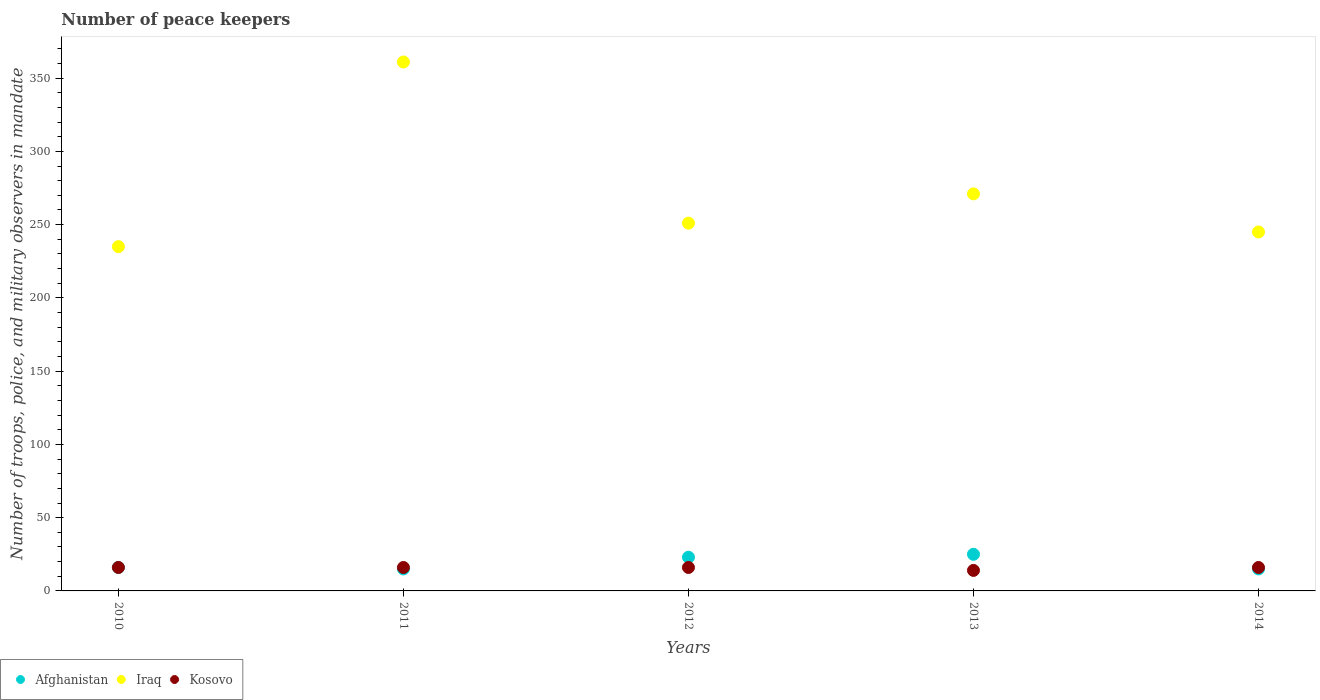What is the number of peace keepers in in Afghanistan in 2014?
Give a very brief answer. 15. Across all years, what is the maximum number of peace keepers in in Afghanistan?
Provide a short and direct response. 25. Across all years, what is the minimum number of peace keepers in in Iraq?
Make the answer very short. 235. In which year was the number of peace keepers in in Afghanistan maximum?
Offer a terse response. 2013. In which year was the number of peace keepers in in Kosovo minimum?
Your response must be concise. 2013. What is the difference between the number of peace keepers in in Iraq in 2013 and the number of peace keepers in in Afghanistan in 2014?
Your answer should be compact. 256. What is the average number of peace keepers in in Iraq per year?
Offer a very short reply. 272.6. In the year 2013, what is the difference between the number of peace keepers in in Kosovo and number of peace keepers in in Iraq?
Make the answer very short. -257. What is the ratio of the number of peace keepers in in Iraq in 2013 to that in 2014?
Provide a succinct answer. 1.11. What is the difference between the highest and the second highest number of peace keepers in in Iraq?
Provide a succinct answer. 90. What is the difference between the highest and the lowest number of peace keepers in in Afghanistan?
Offer a very short reply. 10. In how many years, is the number of peace keepers in in Afghanistan greater than the average number of peace keepers in in Afghanistan taken over all years?
Offer a very short reply. 2. Does the number of peace keepers in in Kosovo monotonically increase over the years?
Ensure brevity in your answer.  No. Is the number of peace keepers in in Iraq strictly less than the number of peace keepers in in Afghanistan over the years?
Make the answer very short. No. How many dotlines are there?
Your response must be concise. 3. How many years are there in the graph?
Give a very brief answer. 5. Does the graph contain any zero values?
Give a very brief answer. No. How many legend labels are there?
Offer a very short reply. 3. How are the legend labels stacked?
Offer a terse response. Horizontal. What is the title of the graph?
Your answer should be very brief. Number of peace keepers. Does "Malaysia" appear as one of the legend labels in the graph?
Ensure brevity in your answer.  No. What is the label or title of the Y-axis?
Your answer should be very brief. Number of troops, police, and military observers in mandate. What is the Number of troops, police, and military observers in mandate in Iraq in 2010?
Your answer should be very brief. 235. What is the Number of troops, police, and military observers in mandate in Afghanistan in 2011?
Provide a short and direct response. 15. What is the Number of troops, police, and military observers in mandate in Iraq in 2011?
Provide a short and direct response. 361. What is the Number of troops, police, and military observers in mandate of Iraq in 2012?
Make the answer very short. 251. What is the Number of troops, police, and military observers in mandate in Kosovo in 2012?
Provide a succinct answer. 16. What is the Number of troops, police, and military observers in mandate of Iraq in 2013?
Your answer should be compact. 271. What is the Number of troops, police, and military observers in mandate in Kosovo in 2013?
Your answer should be compact. 14. What is the Number of troops, police, and military observers in mandate in Afghanistan in 2014?
Make the answer very short. 15. What is the Number of troops, police, and military observers in mandate in Iraq in 2014?
Offer a very short reply. 245. Across all years, what is the maximum Number of troops, police, and military observers in mandate in Afghanistan?
Provide a succinct answer. 25. Across all years, what is the maximum Number of troops, police, and military observers in mandate in Iraq?
Provide a succinct answer. 361. Across all years, what is the minimum Number of troops, police, and military observers in mandate in Afghanistan?
Offer a very short reply. 15. Across all years, what is the minimum Number of troops, police, and military observers in mandate in Iraq?
Offer a terse response. 235. What is the total Number of troops, police, and military observers in mandate in Afghanistan in the graph?
Your response must be concise. 94. What is the total Number of troops, police, and military observers in mandate of Iraq in the graph?
Offer a terse response. 1363. What is the difference between the Number of troops, police, and military observers in mandate of Afghanistan in 2010 and that in 2011?
Ensure brevity in your answer.  1. What is the difference between the Number of troops, police, and military observers in mandate of Iraq in 2010 and that in 2011?
Make the answer very short. -126. What is the difference between the Number of troops, police, and military observers in mandate of Kosovo in 2010 and that in 2012?
Your response must be concise. 0. What is the difference between the Number of troops, police, and military observers in mandate of Afghanistan in 2010 and that in 2013?
Make the answer very short. -9. What is the difference between the Number of troops, police, and military observers in mandate in Iraq in 2010 and that in 2013?
Make the answer very short. -36. What is the difference between the Number of troops, police, and military observers in mandate of Kosovo in 2010 and that in 2014?
Offer a very short reply. 0. What is the difference between the Number of troops, police, and military observers in mandate of Afghanistan in 2011 and that in 2012?
Give a very brief answer. -8. What is the difference between the Number of troops, police, and military observers in mandate of Iraq in 2011 and that in 2012?
Offer a terse response. 110. What is the difference between the Number of troops, police, and military observers in mandate of Afghanistan in 2011 and that in 2013?
Your response must be concise. -10. What is the difference between the Number of troops, police, and military observers in mandate in Iraq in 2011 and that in 2014?
Offer a terse response. 116. What is the difference between the Number of troops, police, and military observers in mandate of Kosovo in 2011 and that in 2014?
Give a very brief answer. 0. What is the difference between the Number of troops, police, and military observers in mandate of Kosovo in 2012 and that in 2013?
Offer a terse response. 2. What is the difference between the Number of troops, police, and military observers in mandate of Afghanistan in 2012 and that in 2014?
Ensure brevity in your answer.  8. What is the difference between the Number of troops, police, and military observers in mandate of Afghanistan in 2013 and that in 2014?
Ensure brevity in your answer.  10. What is the difference between the Number of troops, police, and military observers in mandate in Iraq in 2013 and that in 2014?
Provide a short and direct response. 26. What is the difference between the Number of troops, police, and military observers in mandate in Kosovo in 2013 and that in 2014?
Make the answer very short. -2. What is the difference between the Number of troops, police, and military observers in mandate in Afghanistan in 2010 and the Number of troops, police, and military observers in mandate in Iraq in 2011?
Give a very brief answer. -345. What is the difference between the Number of troops, police, and military observers in mandate of Iraq in 2010 and the Number of troops, police, and military observers in mandate of Kosovo in 2011?
Provide a succinct answer. 219. What is the difference between the Number of troops, police, and military observers in mandate in Afghanistan in 2010 and the Number of troops, police, and military observers in mandate in Iraq in 2012?
Offer a very short reply. -235. What is the difference between the Number of troops, police, and military observers in mandate of Iraq in 2010 and the Number of troops, police, and military observers in mandate of Kosovo in 2012?
Provide a short and direct response. 219. What is the difference between the Number of troops, police, and military observers in mandate in Afghanistan in 2010 and the Number of troops, police, and military observers in mandate in Iraq in 2013?
Provide a succinct answer. -255. What is the difference between the Number of troops, police, and military observers in mandate in Iraq in 2010 and the Number of troops, police, and military observers in mandate in Kosovo in 2013?
Provide a short and direct response. 221. What is the difference between the Number of troops, police, and military observers in mandate in Afghanistan in 2010 and the Number of troops, police, and military observers in mandate in Iraq in 2014?
Provide a short and direct response. -229. What is the difference between the Number of troops, police, and military observers in mandate of Iraq in 2010 and the Number of troops, police, and military observers in mandate of Kosovo in 2014?
Provide a short and direct response. 219. What is the difference between the Number of troops, police, and military observers in mandate of Afghanistan in 2011 and the Number of troops, police, and military observers in mandate of Iraq in 2012?
Offer a very short reply. -236. What is the difference between the Number of troops, police, and military observers in mandate of Afghanistan in 2011 and the Number of troops, police, and military observers in mandate of Kosovo in 2012?
Offer a terse response. -1. What is the difference between the Number of troops, police, and military observers in mandate in Iraq in 2011 and the Number of troops, police, and military observers in mandate in Kosovo in 2012?
Offer a terse response. 345. What is the difference between the Number of troops, police, and military observers in mandate in Afghanistan in 2011 and the Number of troops, police, and military observers in mandate in Iraq in 2013?
Give a very brief answer. -256. What is the difference between the Number of troops, police, and military observers in mandate in Afghanistan in 2011 and the Number of troops, police, and military observers in mandate in Kosovo in 2013?
Provide a succinct answer. 1. What is the difference between the Number of troops, police, and military observers in mandate of Iraq in 2011 and the Number of troops, police, and military observers in mandate of Kosovo in 2013?
Keep it short and to the point. 347. What is the difference between the Number of troops, police, and military observers in mandate of Afghanistan in 2011 and the Number of troops, police, and military observers in mandate of Iraq in 2014?
Give a very brief answer. -230. What is the difference between the Number of troops, police, and military observers in mandate in Iraq in 2011 and the Number of troops, police, and military observers in mandate in Kosovo in 2014?
Keep it short and to the point. 345. What is the difference between the Number of troops, police, and military observers in mandate in Afghanistan in 2012 and the Number of troops, police, and military observers in mandate in Iraq in 2013?
Give a very brief answer. -248. What is the difference between the Number of troops, police, and military observers in mandate of Afghanistan in 2012 and the Number of troops, police, and military observers in mandate of Kosovo in 2013?
Offer a very short reply. 9. What is the difference between the Number of troops, police, and military observers in mandate in Iraq in 2012 and the Number of troops, police, and military observers in mandate in Kosovo in 2013?
Make the answer very short. 237. What is the difference between the Number of troops, police, and military observers in mandate of Afghanistan in 2012 and the Number of troops, police, and military observers in mandate of Iraq in 2014?
Offer a terse response. -222. What is the difference between the Number of troops, police, and military observers in mandate of Afghanistan in 2012 and the Number of troops, police, and military observers in mandate of Kosovo in 2014?
Ensure brevity in your answer.  7. What is the difference between the Number of troops, police, and military observers in mandate in Iraq in 2012 and the Number of troops, police, and military observers in mandate in Kosovo in 2014?
Ensure brevity in your answer.  235. What is the difference between the Number of troops, police, and military observers in mandate in Afghanistan in 2013 and the Number of troops, police, and military observers in mandate in Iraq in 2014?
Offer a very short reply. -220. What is the difference between the Number of troops, police, and military observers in mandate of Iraq in 2013 and the Number of troops, police, and military observers in mandate of Kosovo in 2014?
Make the answer very short. 255. What is the average Number of troops, police, and military observers in mandate of Iraq per year?
Provide a succinct answer. 272.6. What is the average Number of troops, police, and military observers in mandate in Kosovo per year?
Keep it short and to the point. 15.6. In the year 2010, what is the difference between the Number of troops, police, and military observers in mandate in Afghanistan and Number of troops, police, and military observers in mandate in Iraq?
Make the answer very short. -219. In the year 2010, what is the difference between the Number of troops, police, and military observers in mandate in Iraq and Number of troops, police, and military observers in mandate in Kosovo?
Provide a short and direct response. 219. In the year 2011, what is the difference between the Number of troops, police, and military observers in mandate of Afghanistan and Number of troops, police, and military observers in mandate of Iraq?
Ensure brevity in your answer.  -346. In the year 2011, what is the difference between the Number of troops, police, and military observers in mandate in Afghanistan and Number of troops, police, and military observers in mandate in Kosovo?
Offer a very short reply. -1. In the year 2011, what is the difference between the Number of troops, police, and military observers in mandate in Iraq and Number of troops, police, and military observers in mandate in Kosovo?
Keep it short and to the point. 345. In the year 2012, what is the difference between the Number of troops, police, and military observers in mandate of Afghanistan and Number of troops, police, and military observers in mandate of Iraq?
Give a very brief answer. -228. In the year 2012, what is the difference between the Number of troops, police, and military observers in mandate in Afghanistan and Number of troops, police, and military observers in mandate in Kosovo?
Ensure brevity in your answer.  7. In the year 2012, what is the difference between the Number of troops, police, and military observers in mandate in Iraq and Number of troops, police, and military observers in mandate in Kosovo?
Your answer should be very brief. 235. In the year 2013, what is the difference between the Number of troops, police, and military observers in mandate in Afghanistan and Number of troops, police, and military observers in mandate in Iraq?
Your response must be concise. -246. In the year 2013, what is the difference between the Number of troops, police, and military observers in mandate of Iraq and Number of troops, police, and military observers in mandate of Kosovo?
Offer a terse response. 257. In the year 2014, what is the difference between the Number of troops, police, and military observers in mandate in Afghanistan and Number of troops, police, and military observers in mandate in Iraq?
Offer a very short reply. -230. In the year 2014, what is the difference between the Number of troops, police, and military observers in mandate of Afghanistan and Number of troops, police, and military observers in mandate of Kosovo?
Make the answer very short. -1. In the year 2014, what is the difference between the Number of troops, police, and military observers in mandate of Iraq and Number of troops, police, and military observers in mandate of Kosovo?
Make the answer very short. 229. What is the ratio of the Number of troops, police, and military observers in mandate of Afghanistan in 2010 to that in 2011?
Offer a very short reply. 1.07. What is the ratio of the Number of troops, police, and military observers in mandate in Iraq in 2010 to that in 2011?
Offer a very short reply. 0.65. What is the ratio of the Number of troops, police, and military observers in mandate in Afghanistan in 2010 to that in 2012?
Your answer should be very brief. 0.7. What is the ratio of the Number of troops, police, and military observers in mandate in Iraq in 2010 to that in 2012?
Offer a very short reply. 0.94. What is the ratio of the Number of troops, police, and military observers in mandate in Afghanistan in 2010 to that in 2013?
Ensure brevity in your answer.  0.64. What is the ratio of the Number of troops, police, and military observers in mandate in Iraq in 2010 to that in 2013?
Your answer should be compact. 0.87. What is the ratio of the Number of troops, police, and military observers in mandate of Afghanistan in 2010 to that in 2014?
Offer a very short reply. 1.07. What is the ratio of the Number of troops, police, and military observers in mandate in Iraq in 2010 to that in 2014?
Give a very brief answer. 0.96. What is the ratio of the Number of troops, police, and military observers in mandate of Kosovo in 2010 to that in 2014?
Keep it short and to the point. 1. What is the ratio of the Number of troops, police, and military observers in mandate of Afghanistan in 2011 to that in 2012?
Ensure brevity in your answer.  0.65. What is the ratio of the Number of troops, police, and military observers in mandate in Iraq in 2011 to that in 2012?
Your answer should be very brief. 1.44. What is the ratio of the Number of troops, police, and military observers in mandate of Afghanistan in 2011 to that in 2013?
Keep it short and to the point. 0.6. What is the ratio of the Number of troops, police, and military observers in mandate in Iraq in 2011 to that in 2013?
Offer a terse response. 1.33. What is the ratio of the Number of troops, police, and military observers in mandate in Kosovo in 2011 to that in 2013?
Give a very brief answer. 1.14. What is the ratio of the Number of troops, police, and military observers in mandate of Afghanistan in 2011 to that in 2014?
Provide a succinct answer. 1. What is the ratio of the Number of troops, police, and military observers in mandate of Iraq in 2011 to that in 2014?
Provide a succinct answer. 1.47. What is the ratio of the Number of troops, police, and military observers in mandate of Kosovo in 2011 to that in 2014?
Make the answer very short. 1. What is the ratio of the Number of troops, police, and military observers in mandate in Afghanistan in 2012 to that in 2013?
Offer a terse response. 0.92. What is the ratio of the Number of troops, police, and military observers in mandate in Iraq in 2012 to that in 2013?
Keep it short and to the point. 0.93. What is the ratio of the Number of troops, police, and military observers in mandate in Afghanistan in 2012 to that in 2014?
Keep it short and to the point. 1.53. What is the ratio of the Number of troops, police, and military observers in mandate in Iraq in 2012 to that in 2014?
Offer a very short reply. 1.02. What is the ratio of the Number of troops, police, and military observers in mandate in Kosovo in 2012 to that in 2014?
Provide a succinct answer. 1. What is the ratio of the Number of troops, police, and military observers in mandate in Iraq in 2013 to that in 2014?
Provide a short and direct response. 1.11. What is the ratio of the Number of troops, police, and military observers in mandate in Kosovo in 2013 to that in 2014?
Your response must be concise. 0.88. What is the difference between the highest and the second highest Number of troops, police, and military observers in mandate of Afghanistan?
Your response must be concise. 2. What is the difference between the highest and the second highest Number of troops, police, and military observers in mandate in Iraq?
Offer a very short reply. 90. What is the difference between the highest and the lowest Number of troops, police, and military observers in mandate of Afghanistan?
Make the answer very short. 10. What is the difference between the highest and the lowest Number of troops, police, and military observers in mandate of Iraq?
Give a very brief answer. 126. 